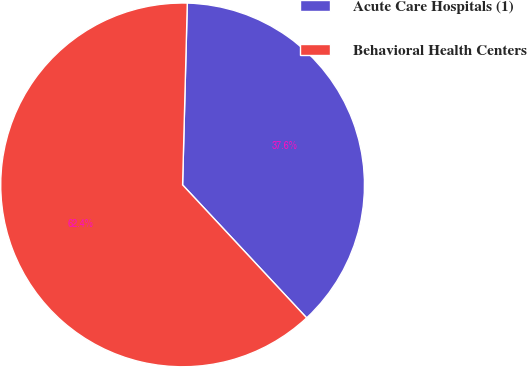Convert chart to OTSL. <chart><loc_0><loc_0><loc_500><loc_500><pie_chart><fcel>Acute Care Hospitals (1)<fcel>Behavioral Health Centers<nl><fcel>37.64%<fcel>62.36%<nl></chart> 